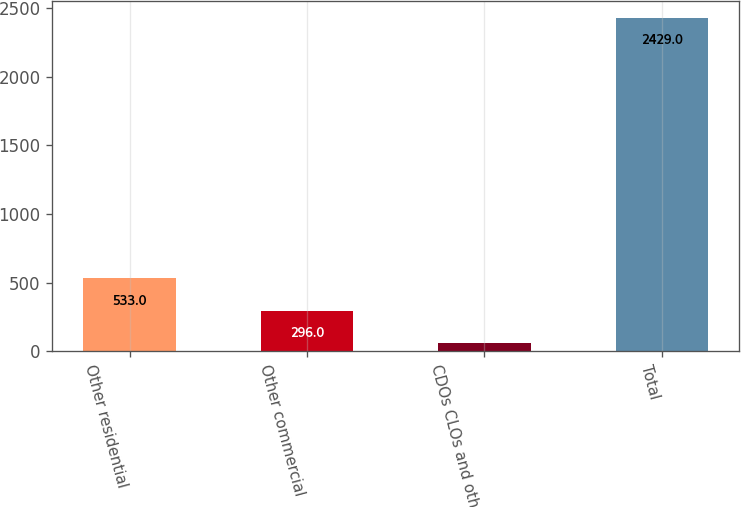Convert chart to OTSL. <chart><loc_0><loc_0><loc_500><loc_500><bar_chart><fcel>Other residential<fcel>Other commercial<fcel>CDOs CLOs and other<fcel>Total<nl><fcel>533<fcel>296<fcel>59<fcel>2429<nl></chart> 